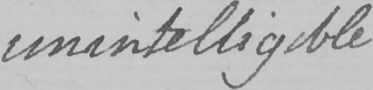Please transcribe the handwritten text in this image. unintelligible 